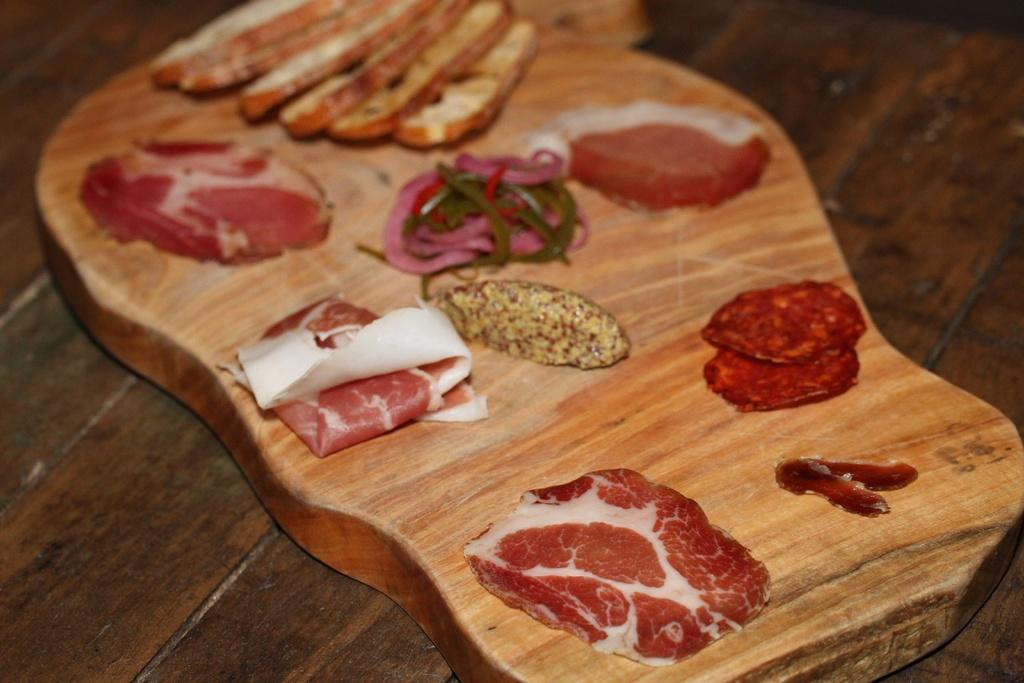What is present in the image that people typically consume? There is food in the image. On what is the food placed? The food is on a wooden block. What is the color of the surface beneath the wooden block? The wooden block is on a brown-colored surface. What type of machine is used to create the food in the image? There is no machine present in the image; the food is simply placed on a wooden block. 